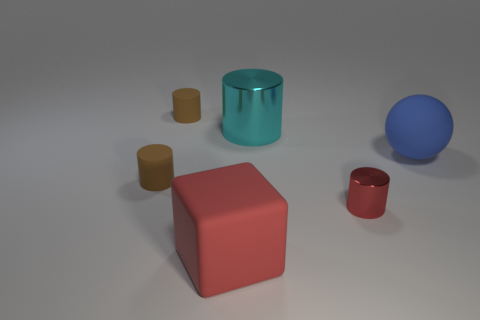Is the number of tiny rubber cylinders behind the cyan metallic cylinder the same as the number of small red cylinders?
Provide a succinct answer. Yes. What shape is the big object that is right of the red rubber thing and in front of the big cyan cylinder?
Offer a very short reply. Sphere. Do the blue object and the red block have the same size?
Provide a succinct answer. Yes. Are there any tiny brown cylinders that have the same material as the big blue thing?
Ensure brevity in your answer.  Yes. There is a metal cylinder that is the same color as the large matte cube; what is its size?
Offer a terse response. Small. How many big objects are behind the large red block and in front of the big metal cylinder?
Your response must be concise. 1. There is a small brown thing that is in front of the big blue sphere; what is it made of?
Provide a short and direct response. Rubber. What number of small cylinders are the same color as the block?
Your answer should be compact. 1. What is the size of the block that is the same material as the big blue ball?
Your response must be concise. Large. How many objects are either small gray objects or tiny matte cylinders?
Keep it short and to the point. 2. 